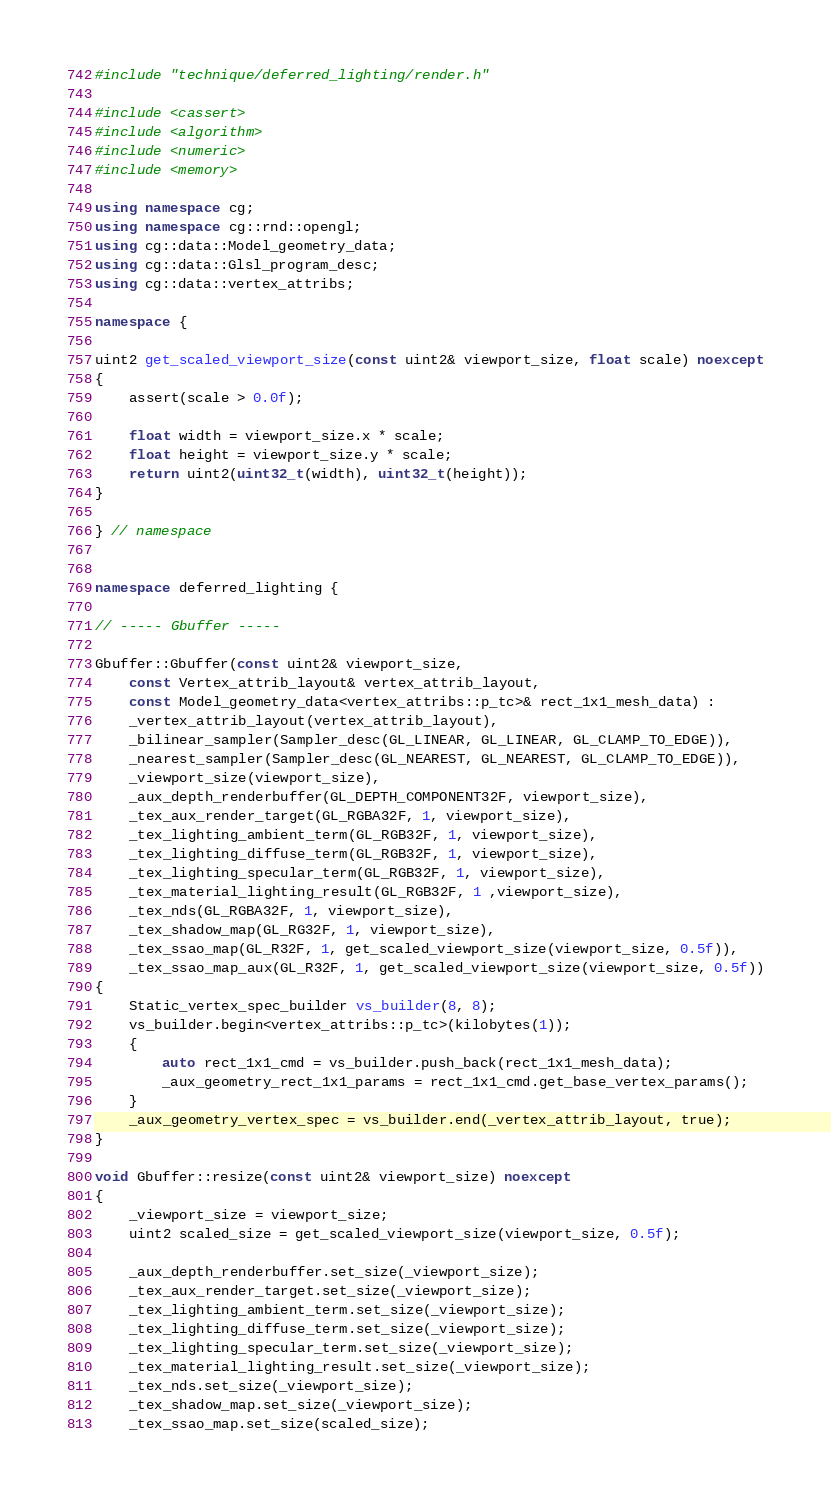Convert code to text. <code><loc_0><loc_0><loc_500><loc_500><_C++_>#include "technique/deferred_lighting/render.h"

#include <cassert>
#include <algorithm>
#include <numeric>
#include <memory>

using namespace cg;
using namespace cg::rnd::opengl;
using cg::data::Model_geometry_data;
using cg::data::Glsl_program_desc;
using cg::data::vertex_attribs;

namespace {

uint2 get_scaled_viewport_size(const uint2& viewport_size, float scale) noexcept
{
	assert(scale > 0.0f);

	float width = viewport_size.x * scale;
	float height = viewport_size.y * scale;
	return uint2(uint32_t(width), uint32_t(height));
}

} // namespace


namespace deferred_lighting {

// ----- Gbuffer -----

Gbuffer::Gbuffer(const uint2& viewport_size,
	const Vertex_attrib_layout& vertex_attrib_layout,
	const Model_geometry_data<vertex_attribs::p_tc>& rect_1x1_mesh_data) :
	_vertex_attrib_layout(vertex_attrib_layout),
	_bilinear_sampler(Sampler_desc(GL_LINEAR, GL_LINEAR, GL_CLAMP_TO_EDGE)),
	_nearest_sampler(Sampler_desc(GL_NEAREST, GL_NEAREST, GL_CLAMP_TO_EDGE)),
	_viewport_size(viewport_size),
	_aux_depth_renderbuffer(GL_DEPTH_COMPONENT32F, viewport_size),
	_tex_aux_render_target(GL_RGBA32F, 1, viewport_size),
	_tex_lighting_ambient_term(GL_RGB32F, 1, viewport_size),
	_tex_lighting_diffuse_term(GL_RGB32F, 1, viewport_size),
	_tex_lighting_specular_term(GL_RGB32F, 1, viewport_size),
	_tex_material_lighting_result(GL_RGB32F, 1 ,viewport_size),
	_tex_nds(GL_RGBA32F, 1, viewport_size),
	_tex_shadow_map(GL_RG32F, 1, viewport_size),
	_tex_ssao_map(GL_R32F, 1, get_scaled_viewport_size(viewport_size, 0.5f)),
	_tex_ssao_map_aux(GL_R32F, 1, get_scaled_viewport_size(viewport_size, 0.5f))
{
	Static_vertex_spec_builder vs_builder(8, 8);
	vs_builder.begin<vertex_attribs::p_tc>(kilobytes(1));
	{
		auto rect_1x1_cmd = vs_builder.push_back(rect_1x1_mesh_data);
		_aux_geometry_rect_1x1_params = rect_1x1_cmd.get_base_vertex_params();
	}
	_aux_geometry_vertex_spec = vs_builder.end(_vertex_attrib_layout, true);
}

void Gbuffer::resize(const uint2& viewport_size) noexcept
{
	_viewport_size = viewport_size;
	uint2 scaled_size = get_scaled_viewport_size(viewport_size, 0.5f);

	_aux_depth_renderbuffer.set_size(_viewport_size);
	_tex_aux_render_target.set_size(_viewport_size);
	_tex_lighting_ambient_term.set_size(_viewport_size);
	_tex_lighting_diffuse_term.set_size(_viewport_size);
	_tex_lighting_specular_term.set_size(_viewport_size);
	_tex_material_lighting_result.set_size(_viewport_size);
	_tex_nds.set_size(_viewport_size);
	_tex_shadow_map.set_size(_viewport_size);
	_tex_ssao_map.set_size(scaled_size);</code> 